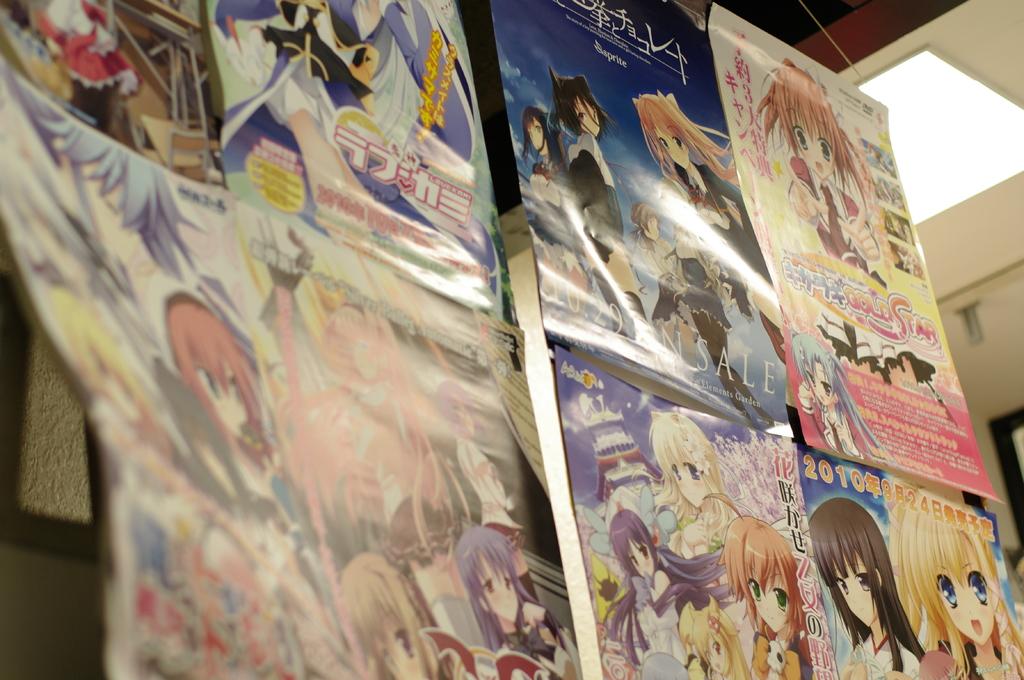Is that in a foreign language?
Your answer should be very brief. Yes. What year is printed on the very bottom right poster?
Give a very brief answer. 2010. 